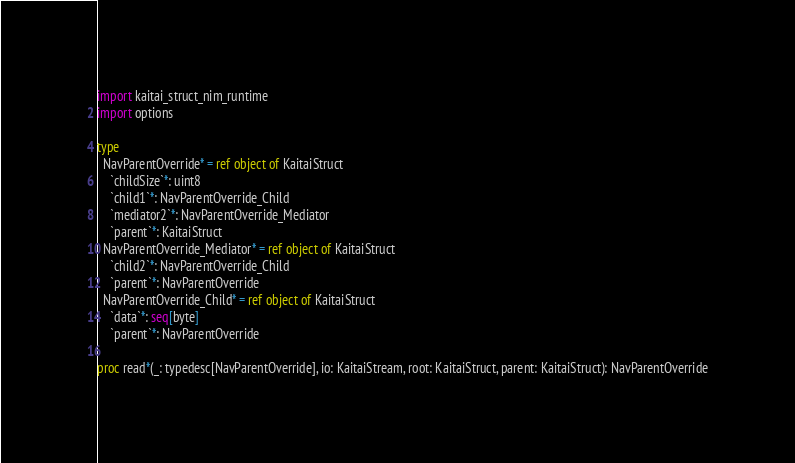Convert code to text. <code><loc_0><loc_0><loc_500><loc_500><_Nim_>import kaitai_struct_nim_runtime
import options

type
  NavParentOverride* = ref object of KaitaiStruct
    `childSize`*: uint8
    `child1`*: NavParentOverride_Child
    `mediator2`*: NavParentOverride_Mediator
    `parent`*: KaitaiStruct
  NavParentOverride_Mediator* = ref object of KaitaiStruct
    `child2`*: NavParentOverride_Child
    `parent`*: NavParentOverride
  NavParentOverride_Child* = ref object of KaitaiStruct
    `data`*: seq[byte]
    `parent`*: NavParentOverride

proc read*(_: typedesc[NavParentOverride], io: KaitaiStream, root: KaitaiStruct, parent: KaitaiStruct): NavParentOverride</code> 